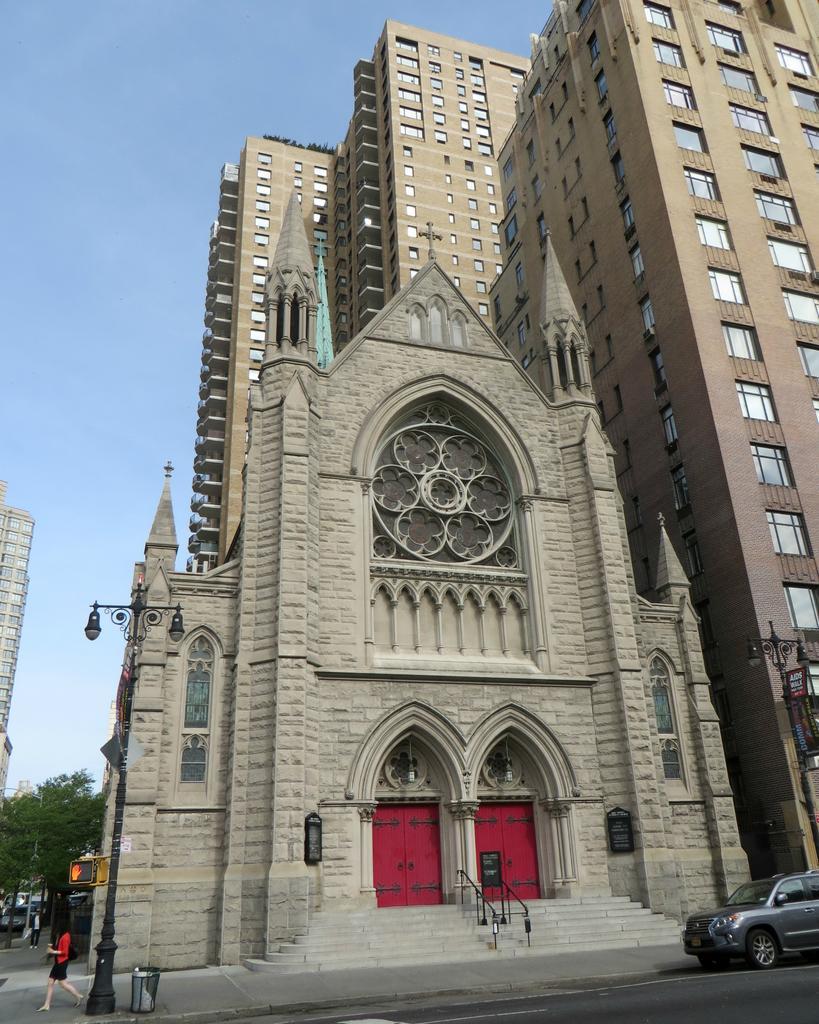Can you describe this image briefly? In this image we can see one church, some buildings, four objects attached to the church, one board with text attached to the poles, one staircase, one car on the road on the right side of the image, some lights with poles, some objects attached to the poles, some trees, some vehicles on the road on the left side of the image, one dustbin near the pole, few objects on the bottom left side of the image, some objects in the dustbin, two persons walking on the footpath and holding objects. 